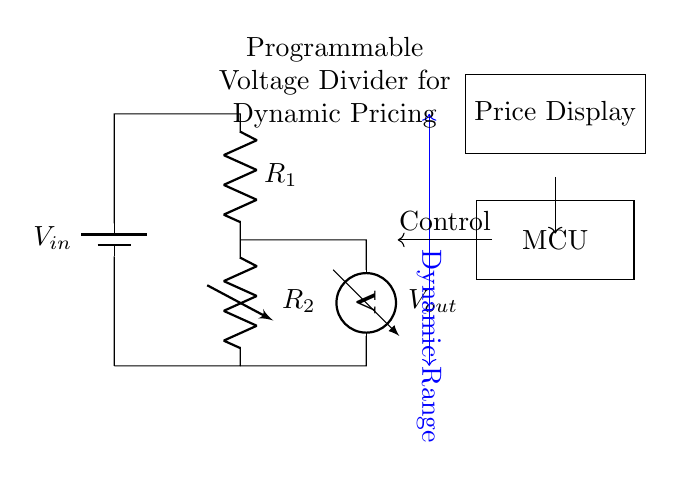What is the input voltage in the circuit? The input voltage is denoted as V-in, which is found at the top left side of the circuit diagram where the battery is represented.
Answer: V-in What component is used to adjust the output voltage? The variable resistor, labeled as R-2 in the diagram, allows for the adjustment of the output voltage by changing its resistance.
Answer: R-2 What is the role of the MCU in this circuit? The MCU (Microcontroller Unit) acts as a control mechanism, receiving signals from the voltage divider and adjusting the operation of the circuit to achieve the desired output for dynamic pricing displays.
Answer: Control mechanism What voltage is measured across R-1? The voltmeter, connected parallel to R-1, measures V-out, which represents the output voltage after the voltage divider.
Answer: V-out How does the dynamic range relate to the circuit? The dynamic range indicated by the blue arrow shows the variation of output voltage V-out as the resistance R-2 is adjusted, which directly influences dynamic pricing capabilities.
Answer: Variation of output voltage What is the output voltage's dependence on R-1 and R-2? The output voltage V-out is determined by the ratio of the resistances R-1 and R-2 according to the voltage divider rule, which states that V-out equals V-in times R-2 over the total resistance R-1 plus R-2.
Answer: Ratio of resistances 